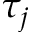Convert formula to latex. <formula><loc_0><loc_0><loc_500><loc_500>\tau _ { j }</formula> 